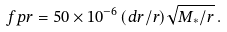<formula> <loc_0><loc_0><loc_500><loc_500>\ f p r = 5 0 \times 1 0 ^ { - 6 } \, ( d r / r ) \sqrt { M _ { * } / r } \, .</formula> 